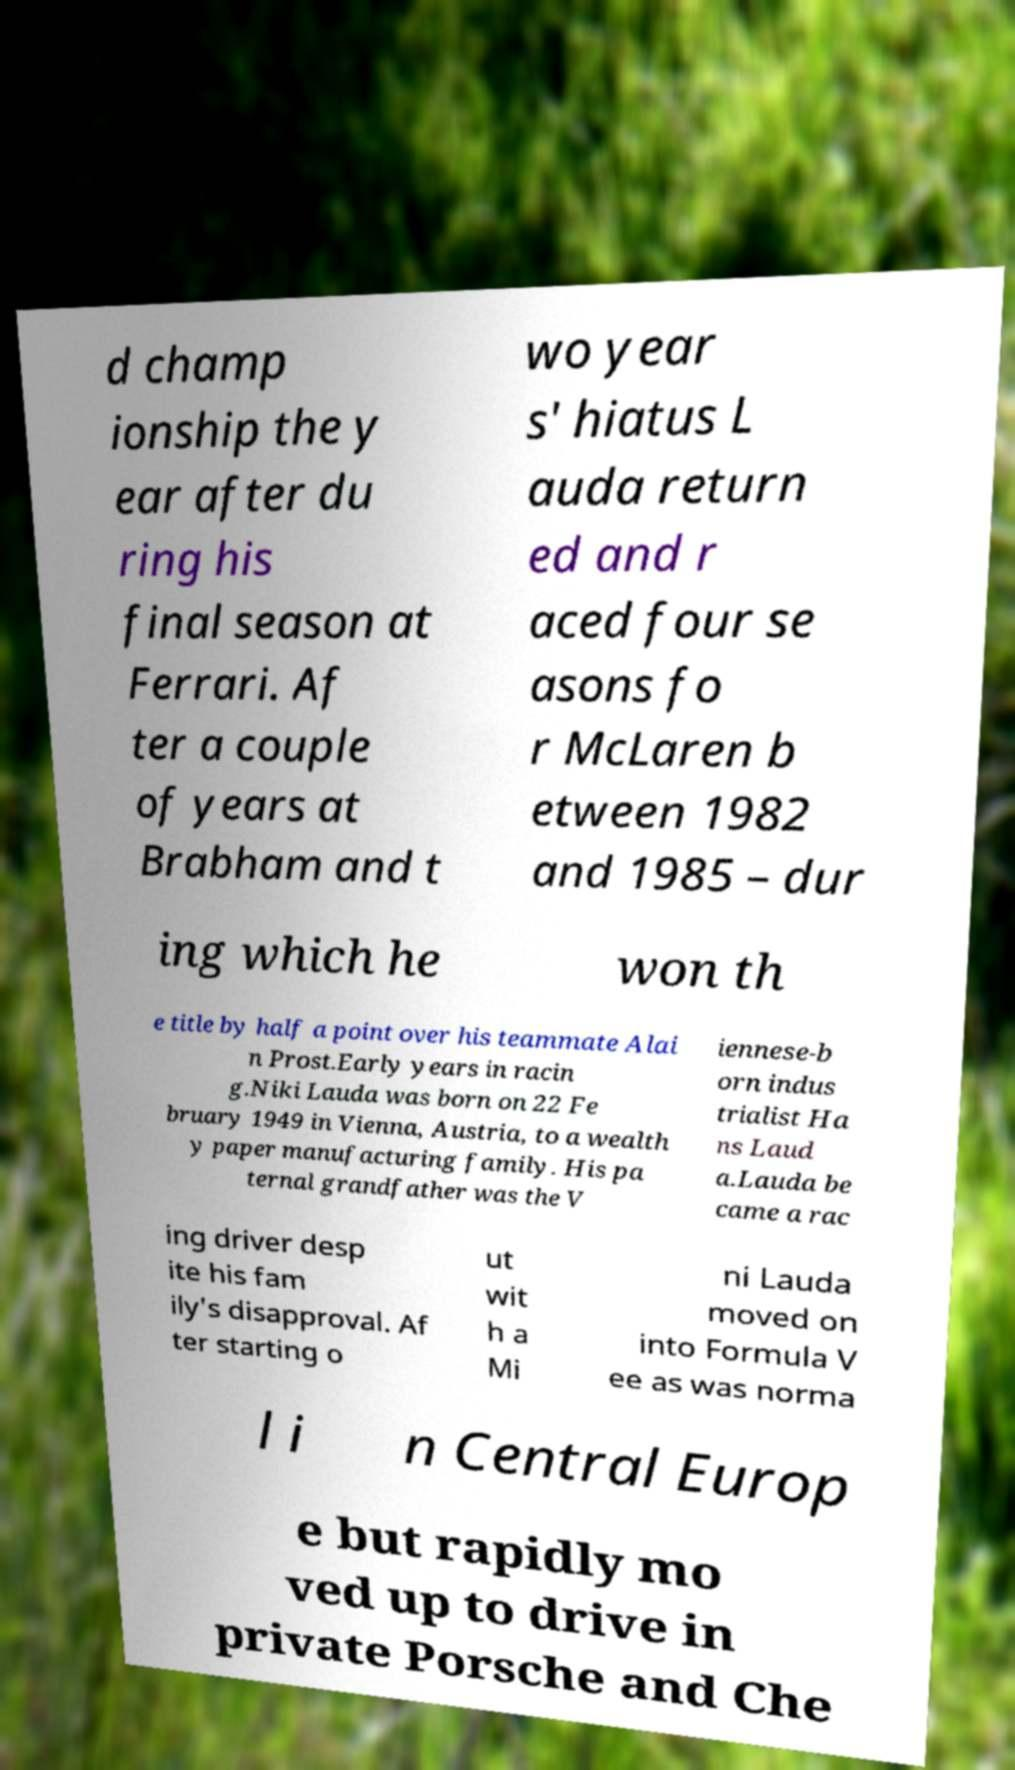Can you read and provide the text displayed in the image?This photo seems to have some interesting text. Can you extract and type it out for me? d champ ionship the y ear after du ring his final season at Ferrari. Af ter a couple of years at Brabham and t wo year s' hiatus L auda return ed and r aced four se asons fo r McLaren b etween 1982 and 1985 – dur ing which he won th e title by half a point over his teammate Alai n Prost.Early years in racin g.Niki Lauda was born on 22 Fe bruary 1949 in Vienna, Austria, to a wealth y paper manufacturing family. His pa ternal grandfather was the V iennese-b orn indus trialist Ha ns Laud a.Lauda be came a rac ing driver desp ite his fam ily's disapproval. Af ter starting o ut wit h a Mi ni Lauda moved on into Formula V ee as was norma l i n Central Europ e but rapidly mo ved up to drive in private Porsche and Che 